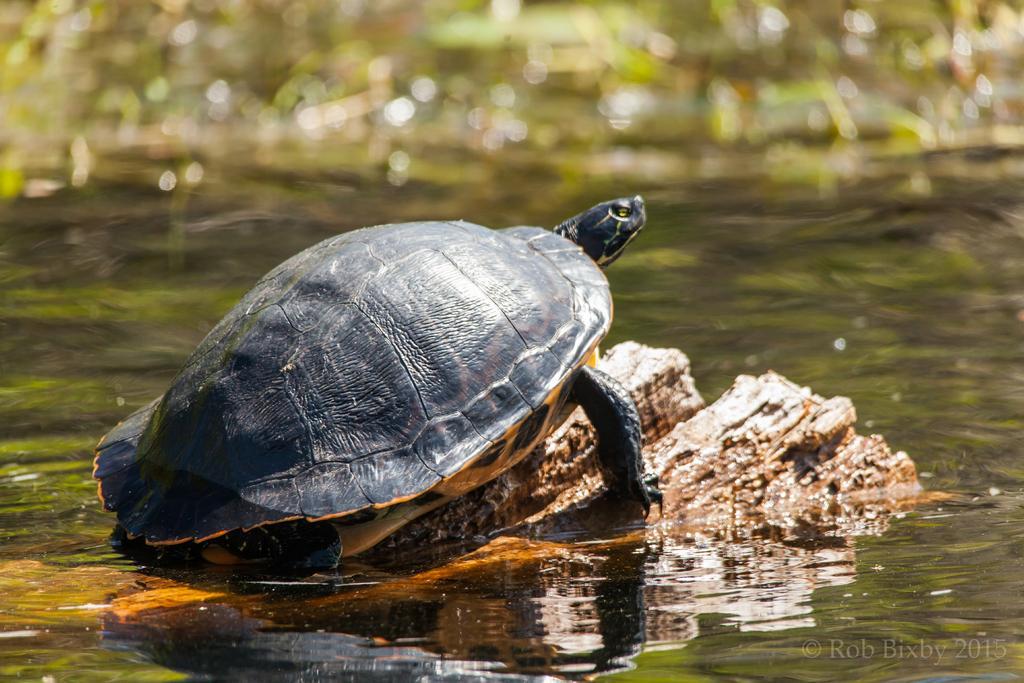In one or two sentences, can you explain what this image depicts? In this image, we can see a black tortoise on the rock and we can see water. 